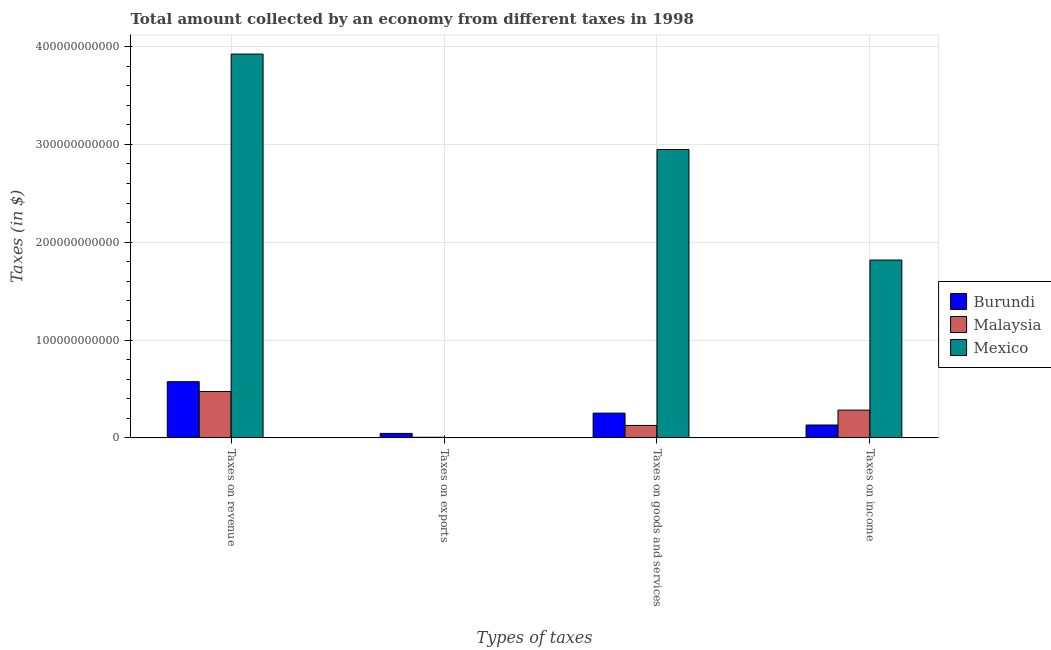How many different coloured bars are there?
Provide a short and direct response. 3. How many bars are there on the 2nd tick from the left?
Provide a short and direct response. 3. How many bars are there on the 4th tick from the right?
Ensure brevity in your answer.  3. What is the label of the 1st group of bars from the left?
Offer a terse response. Taxes on revenue. What is the amount collected as tax on income in Mexico?
Provide a short and direct response. 1.82e+11. Across all countries, what is the maximum amount collected as tax on revenue?
Make the answer very short. 3.92e+11. Across all countries, what is the minimum amount collected as tax on exports?
Provide a short and direct response. 1.00e+06. In which country was the amount collected as tax on income maximum?
Ensure brevity in your answer.  Mexico. In which country was the amount collected as tax on goods minimum?
Make the answer very short. Malaysia. What is the total amount collected as tax on goods in the graph?
Provide a short and direct response. 3.33e+11. What is the difference between the amount collected as tax on goods in Burundi and that in Mexico?
Provide a short and direct response. -2.69e+11. What is the difference between the amount collected as tax on exports in Malaysia and the amount collected as tax on goods in Burundi?
Provide a short and direct response. -2.47e+1. What is the average amount collected as tax on income per country?
Offer a terse response. 7.44e+1. What is the difference between the amount collected as tax on revenue and amount collected as tax on income in Burundi?
Give a very brief answer. 4.43e+1. In how many countries, is the amount collected as tax on goods greater than 240000000000 $?
Make the answer very short. 1. What is the ratio of the amount collected as tax on income in Malaysia to that in Mexico?
Offer a terse response. 0.16. What is the difference between the highest and the second highest amount collected as tax on goods?
Provide a succinct answer. 2.69e+11. What is the difference between the highest and the lowest amount collected as tax on goods?
Offer a terse response. 2.82e+11. In how many countries, is the amount collected as tax on revenue greater than the average amount collected as tax on revenue taken over all countries?
Your response must be concise. 1. Is it the case that in every country, the sum of the amount collected as tax on revenue and amount collected as tax on income is greater than the sum of amount collected as tax on goods and amount collected as tax on exports?
Give a very brief answer. No. What does the 2nd bar from the left in Taxes on goods and services represents?
Provide a short and direct response. Malaysia. What does the 2nd bar from the right in Taxes on goods and services represents?
Offer a very short reply. Malaysia. How many bars are there?
Provide a short and direct response. 12. Are all the bars in the graph horizontal?
Ensure brevity in your answer.  No. How many countries are there in the graph?
Offer a terse response. 3. What is the difference between two consecutive major ticks on the Y-axis?
Give a very brief answer. 1.00e+11. Does the graph contain any zero values?
Ensure brevity in your answer.  No. Where does the legend appear in the graph?
Keep it short and to the point. Center right. How many legend labels are there?
Offer a terse response. 3. How are the legend labels stacked?
Provide a short and direct response. Vertical. What is the title of the graph?
Keep it short and to the point. Total amount collected by an economy from different taxes in 1998. What is the label or title of the X-axis?
Make the answer very short. Types of taxes. What is the label or title of the Y-axis?
Your response must be concise. Taxes (in $). What is the Taxes (in $) in Burundi in Taxes on revenue?
Your answer should be very brief. 5.74e+1. What is the Taxes (in $) in Malaysia in Taxes on revenue?
Ensure brevity in your answer.  4.74e+1. What is the Taxes (in $) in Mexico in Taxes on revenue?
Your response must be concise. 3.92e+11. What is the Taxes (in $) of Burundi in Taxes on exports?
Provide a short and direct response. 4.56e+09. What is the Taxes (in $) of Malaysia in Taxes on exports?
Provide a short and direct response. 6.23e+08. What is the Taxes (in $) in Mexico in Taxes on exports?
Your answer should be compact. 1.00e+06. What is the Taxes (in $) of Burundi in Taxes on goods and services?
Ensure brevity in your answer.  2.53e+1. What is the Taxes (in $) of Malaysia in Taxes on goods and services?
Give a very brief answer. 1.27e+1. What is the Taxes (in $) of Mexico in Taxes on goods and services?
Your answer should be very brief. 2.95e+11. What is the Taxes (in $) of Burundi in Taxes on income?
Offer a very short reply. 1.31e+1. What is the Taxes (in $) of Malaysia in Taxes on income?
Give a very brief answer. 2.84e+1. What is the Taxes (in $) in Mexico in Taxes on income?
Your answer should be compact. 1.82e+11. Across all Types of taxes, what is the maximum Taxes (in $) in Burundi?
Your response must be concise. 5.74e+1. Across all Types of taxes, what is the maximum Taxes (in $) of Malaysia?
Offer a terse response. 4.74e+1. Across all Types of taxes, what is the maximum Taxes (in $) in Mexico?
Your response must be concise. 3.92e+11. Across all Types of taxes, what is the minimum Taxes (in $) in Burundi?
Your answer should be very brief. 4.56e+09. Across all Types of taxes, what is the minimum Taxes (in $) in Malaysia?
Make the answer very short. 6.23e+08. Across all Types of taxes, what is the minimum Taxes (in $) of Mexico?
Your answer should be compact. 1.00e+06. What is the total Taxes (in $) in Burundi in the graph?
Your answer should be compact. 1.00e+11. What is the total Taxes (in $) of Malaysia in the graph?
Offer a very short reply. 8.91e+1. What is the total Taxes (in $) in Mexico in the graph?
Provide a succinct answer. 8.69e+11. What is the difference between the Taxes (in $) of Burundi in Taxes on revenue and that in Taxes on exports?
Make the answer very short. 5.29e+1. What is the difference between the Taxes (in $) of Malaysia in Taxes on revenue and that in Taxes on exports?
Provide a short and direct response. 4.68e+1. What is the difference between the Taxes (in $) of Mexico in Taxes on revenue and that in Taxes on exports?
Offer a very short reply. 3.92e+11. What is the difference between the Taxes (in $) of Burundi in Taxes on revenue and that in Taxes on goods and services?
Offer a terse response. 3.21e+1. What is the difference between the Taxes (in $) in Malaysia in Taxes on revenue and that in Taxes on goods and services?
Keep it short and to the point. 3.47e+1. What is the difference between the Taxes (in $) in Mexico in Taxes on revenue and that in Taxes on goods and services?
Offer a very short reply. 9.75e+1. What is the difference between the Taxes (in $) in Burundi in Taxes on revenue and that in Taxes on income?
Your answer should be very brief. 4.43e+1. What is the difference between the Taxes (in $) in Malaysia in Taxes on revenue and that in Taxes on income?
Ensure brevity in your answer.  1.90e+1. What is the difference between the Taxes (in $) in Mexico in Taxes on revenue and that in Taxes on income?
Ensure brevity in your answer.  2.11e+11. What is the difference between the Taxes (in $) of Burundi in Taxes on exports and that in Taxes on goods and services?
Your answer should be very brief. -2.07e+1. What is the difference between the Taxes (in $) of Malaysia in Taxes on exports and that in Taxes on goods and services?
Provide a succinct answer. -1.21e+1. What is the difference between the Taxes (in $) of Mexico in Taxes on exports and that in Taxes on goods and services?
Give a very brief answer. -2.95e+11. What is the difference between the Taxes (in $) in Burundi in Taxes on exports and that in Taxes on income?
Keep it short and to the point. -8.58e+09. What is the difference between the Taxes (in $) in Malaysia in Taxes on exports and that in Taxes on income?
Ensure brevity in your answer.  -2.77e+1. What is the difference between the Taxes (in $) of Mexico in Taxes on exports and that in Taxes on income?
Your answer should be very brief. -1.82e+11. What is the difference between the Taxes (in $) of Burundi in Taxes on goods and services and that in Taxes on income?
Your answer should be very brief. 1.22e+1. What is the difference between the Taxes (in $) in Malaysia in Taxes on goods and services and that in Taxes on income?
Provide a succinct answer. -1.57e+1. What is the difference between the Taxes (in $) of Mexico in Taxes on goods and services and that in Taxes on income?
Provide a short and direct response. 1.13e+11. What is the difference between the Taxes (in $) in Burundi in Taxes on revenue and the Taxes (in $) in Malaysia in Taxes on exports?
Keep it short and to the point. 5.68e+1. What is the difference between the Taxes (in $) in Burundi in Taxes on revenue and the Taxes (in $) in Mexico in Taxes on exports?
Offer a very short reply. 5.74e+1. What is the difference between the Taxes (in $) of Malaysia in Taxes on revenue and the Taxes (in $) of Mexico in Taxes on exports?
Keep it short and to the point. 4.74e+1. What is the difference between the Taxes (in $) in Burundi in Taxes on revenue and the Taxes (in $) in Malaysia in Taxes on goods and services?
Provide a succinct answer. 4.47e+1. What is the difference between the Taxes (in $) of Burundi in Taxes on revenue and the Taxes (in $) of Mexico in Taxes on goods and services?
Provide a succinct answer. -2.37e+11. What is the difference between the Taxes (in $) of Malaysia in Taxes on revenue and the Taxes (in $) of Mexico in Taxes on goods and services?
Make the answer very short. -2.47e+11. What is the difference between the Taxes (in $) of Burundi in Taxes on revenue and the Taxes (in $) of Malaysia in Taxes on income?
Your answer should be compact. 2.91e+1. What is the difference between the Taxes (in $) of Burundi in Taxes on revenue and the Taxes (in $) of Mexico in Taxes on income?
Your answer should be very brief. -1.24e+11. What is the difference between the Taxes (in $) in Malaysia in Taxes on revenue and the Taxes (in $) in Mexico in Taxes on income?
Offer a terse response. -1.34e+11. What is the difference between the Taxes (in $) of Burundi in Taxes on exports and the Taxes (in $) of Malaysia in Taxes on goods and services?
Provide a succinct answer. -8.15e+09. What is the difference between the Taxes (in $) in Burundi in Taxes on exports and the Taxes (in $) in Mexico in Taxes on goods and services?
Your response must be concise. -2.90e+11. What is the difference between the Taxes (in $) in Malaysia in Taxes on exports and the Taxes (in $) in Mexico in Taxes on goods and services?
Give a very brief answer. -2.94e+11. What is the difference between the Taxes (in $) of Burundi in Taxes on exports and the Taxes (in $) of Malaysia in Taxes on income?
Provide a succinct answer. -2.38e+1. What is the difference between the Taxes (in $) in Burundi in Taxes on exports and the Taxes (in $) in Mexico in Taxes on income?
Give a very brief answer. -1.77e+11. What is the difference between the Taxes (in $) in Malaysia in Taxes on exports and the Taxes (in $) in Mexico in Taxes on income?
Your answer should be compact. -1.81e+11. What is the difference between the Taxes (in $) in Burundi in Taxes on goods and services and the Taxes (in $) in Malaysia in Taxes on income?
Your answer should be very brief. -3.06e+09. What is the difference between the Taxes (in $) of Burundi in Taxes on goods and services and the Taxes (in $) of Mexico in Taxes on income?
Provide a succinct answer. -1.56e+11. What is the difference between the Taxes (in $) in Malaysia in Taxes on goods and services and the Taxes (in $) in Mexico in Taxes on income?
Your response must be concise. -1.69e+11. What is the average Taxes (in $) in Burundi per Types of taxes?
Offer a terse response. 2.51e+1. What is the average Taxes (in $) of Malaysia per Types of taxes?
Your answer should be very brief. 2.23e+1. What is the average Taxes (in $) of Mexico per Types of taxes?
Give a very brief answer. 2.17e+11. What is the difference between the Taxes (in $) of Burundi and Taxes (in $) of Malaysia in Taxes on revenue?
Offer a very short reply. 1.00e+1. What is the difference between the Taxes (in $) in Burundi and Taxes (in $) in Mexico in Taxes on revenue?
Keep it short and to the point. -3.35e+11. What is the difference between the Taxes (in $) in Malaysia and Taxes (in $) in Mexico in Taxes on revenue?
Your response must be concise. -3.45e+11. What is the difference between the Taxes (in $) in Burundi and Taxes (in $) in Malaysia in Taxes on exports?
Keep it short and to the point. 3.94e+09. What is the difference between the Taxes (in $) in Burundi and Taxes (in $) in Mexico in Taxes on exports?
Keep it short and to the point. 4.56e+09. What is the difference between the Taxes (in $) in Malaysia and Taxes (in $) in Mexico in Taxes on exports?
Provide a short and direct response. 6.22e+08. What is the difference between the Taxes (in $) of Burundi and Taxes (in $) of Malaysia in Taxes on goods and services?
Your response must be concise. 1.26e+1. What is the difference between the Taxes (in $) of Burundi and Taxes (in $) of Mexico in Taxes on goods and services?
Your answer should be compact. -2.69e+11. What is the difference between the Taxes (in $) of Malaysia and Taxes (in $) of Mexico in Taxes on goods and services?
Your answer should be compact. -2.82e+11. What is the difference between the Taxes (in $) in Burundi and Taxes (in $) in Malaysia in Taxes on income?
Offer a very short reply. -1.52e+1. What is the difference between the Taxes (in $) of Burundi and Taxes (in $) of Mexico in Taxes on income?
Give a very brief answer. -1.69e+11. What is the difference between the Taxes (in $) in Malaysia and Taxes (in $) in Mexico in Taxes on income?
Keep it short and to the point. -1.53e+11. What is the ratio of the Taxes (in $) in Burundi in Taxes on revenue to that in Taxes on exports?
Ensure brevity in your answer.  12.59. What is the ratio of the Taxes (in $) of Malaysia in Taxes on revenue to that in Taxes on exports?
Your response must be concise. 76.06. What is the ratio of the Taxes (in $) of Mexico in Taxes on revenue to that in Taxes on exports?
Your response must be concise. 3.92e+05. What is the ratio of the Taxes (in $) in Burundi in Taxes on revenue to that in Taxes on goods and services?
Keep it short and to the point. 2.27. What is the ratio of the Taxes (in $) in Malaysia in Taxes on revenue to that in Taxes on goods and services?
Your answer should be very brief. 3.73. What is the ratio of the Taxes (in $) in Mexico in Taxes on revenue to that in Taxes on goods and services?
Offer a very short reply. 1.33. What is the ratio of the Taxes (in $) in Burundi in Taxes on revenue to that in Taxes on income?
Provide a short and direct response. 4.37. What is the ratio of the Taxes (in $) of Malaysia in Taxes on revenue to that in Taxes on income?
Provide a short and direct response. 1.67. What is the ratio of the Taxes (in $) of Mexico in Taxes on revenue to that in Taxes on income?
Keep it short and to the point. 2.16. What is the ratio of the Taxes (in $) of Burundi in Taxes on exports to that in Taxes on goods and services?
Offer a terse response. 0.18. What is the ratio of the Taxes (in $) in Malaysia in Taxes on exports to that in Taxes on goods and services?
Offer a very short reply. 0.05. What is the ratio of the Taxes (in $) of Burundi in Taxes on exports to that in Taxes on income?
Make the answer very short. 0.35. What is the ratio of the Taxes (in $) of Malaysia in Taxes on exports to that in Taxes on income?
Your answer should be very brief. 0.02. What is the ratio of the Taxes (in $) of Mexico in Taxes on exports to that in Taxes on income?
Your response must be concise. 0. What is the ratio of the Taxes (in $) of Burundi in Taxes on goods and services to that in Taxes on income?
Give a very brief answer. 1.93. What is the ratio of the Taxes (in $) in Malaysia in Taxes on goods and services to that in Taxes on income?
Keep it short and to the point. 0.45. What is the ratio of the Taxes (in $) of Mexico in Taxes on goods and services to that in Taxes on income?
Your response must be concise. 1.62. What is the difference between the highest and the second highest Taxes (in $) in Burundi?
Make the answer very short. 3.21e+1. What is the difference between the highest and the second highest Taxes (in $) in Malaysia?
Make the answer very short. 1.90e+1. What is the difference between the highest and the second highest Taxes (in $) of Mexico?
Keep it short and to the point. 9.75e+1. What is the difference between the highest and the lowest Taxes (in $) in Burundi?
Your answer should be compact. 5.29e+1. What is the difference between the highest and the lowest Taxes (in $) in Malaysia?
Give a very brief answer. 4.68e+1. What is the difference between the highest and the lowest Taxes (in $) of Mexico?
Keep it short and to the point. 3.92e+11. 